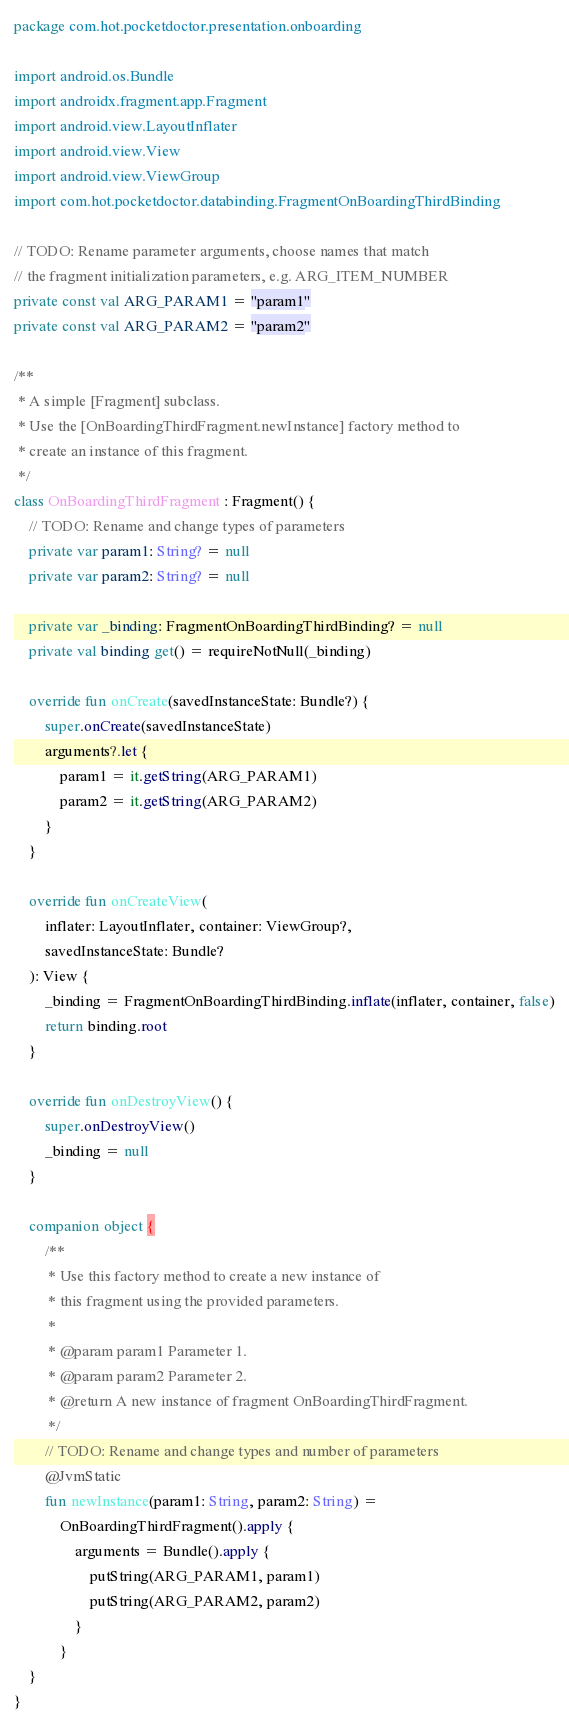Convert code to text. <code><loc_0><loc_0><loc_500><loc_500><_Kotlin_>package com.hot.pocketdoctor.presentation.onboarding

import android.os.Bundle
import androidx.fragment.app.Fragment
import android.view.LayoutInflater
import android.view.View
import android.view.ViewGroup
import com.hot.pocketdoctor.databinding.FragmentOnBoardingThirdBinding

// TODO: Rename parameter arguments, choose names that match
// the fragment initialization parameters, e.g. ARG_ITEM_NUMBER
private const val ARG_PARAM1 = "param1"
private const val ARG_PARAM2 = "param2"

/**
 * A simple [Fragment] subclass.
 * Use the [OnBoardingThirdFragment.newInstance] factory method to
 * create an instance of this fragment.
 */
class OnBoardingThirdFragment : Fragment() {
    // TODO: Rename and change types of parameters
    private var param1: String? = null
    private var param2: String? = null

    private var _binding: FragmentOnBoardingThirdBinding? = null
    private val binding get() = requireNotNull(_binding)

    override fun onCreate(savedInstanceState: Bundle?) {
        super.onCreate(savedInstanceState)
        arguments?.let {
            param1 = it.getString(ARG_PARAM1)
            param2 = it.getString(ARG_PARAM2)
        }
    }

    override fun onCreateView(
        inflater: LayoutInflater, container: ViewGroup?,
        savedInstanceState: Bundle?
    ): View {
        _binding = FragmentOnBoardingThirdBinding.inflate(inflater, container, false)
        return binding.root
    }

    override fun onDestroyView() {
        super.onDestroyView()
        _binding = null
    }

    companion object {
        /**
         * Use this factory method to create a new instance of
         * this fragment using the provided parameters.
         *
         * @param param1 Parameter 1.
         * @param param2 Parameter 2.
         * @return A new instance of fragment OnBoardingThirdFragment.
         */
        // TODO: Rename and change types and number of parameters
        @JvmStatic
        fun newInstance(param1: String, param2: String) =
            OnBoardingThirdFragment().apply {
                arguments = Bundle().apply {
                    putString(ARG_PARAM1, param1)
                    putString(ARG_PARAM2, param2)
                }
            }
    }
}</code> 